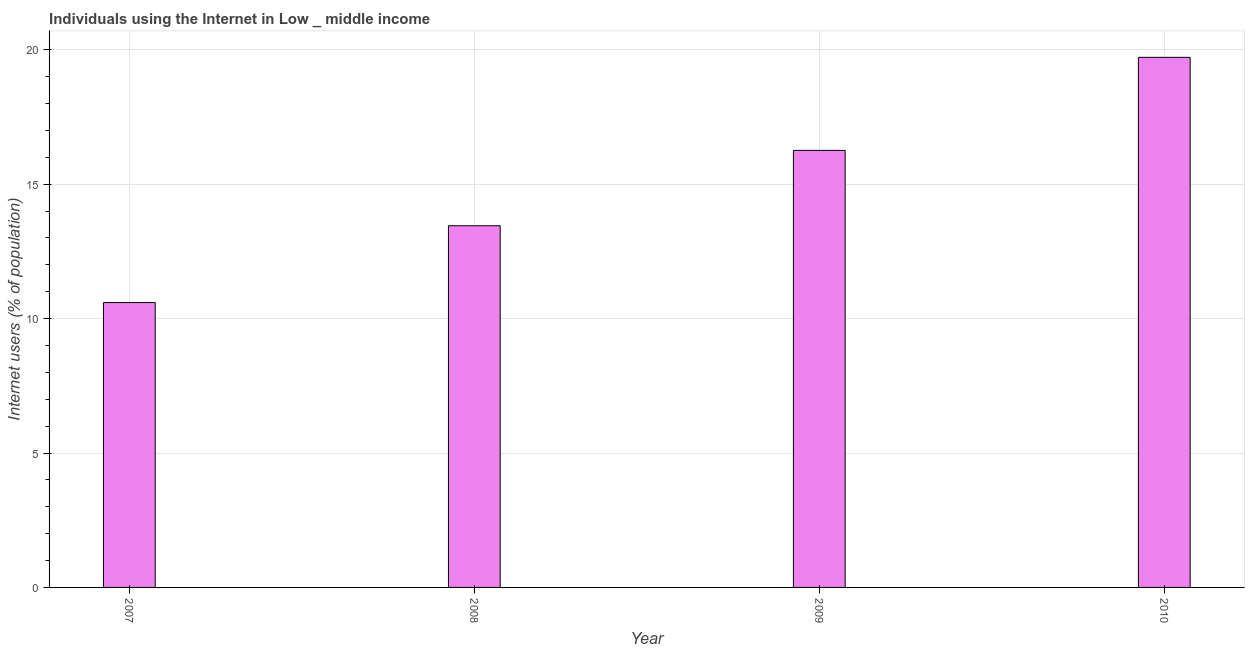Does the graph contain any zero values?
Give a very brief answer. No. What is the title of the graph?
Give a very brief answer. Individuals using the Internet in Low _ middle income. What is the label or title of the Y-axis?
Give a very brief answer. Internet users (% of population). What is the number of internet users in 2008?
Offer a very short reply. 13.46. Across all years, what is the maximum number of internet users?
Offer a very short reply. 19.72. Across all years, what is the minimum number of internet users?
Your response must be concise. 10.6. What is the sum of the number of internet users?
Offer a terse response. 60.03. What is the difference between the number of internet users in 2008 and 2010?
Provide a succinct answer. -6.27. What is the average number of internet users per year?
Give a very brief answer. 15.01. What is the median number of internet users?
Your answer should be compact. 14.86. What is the ratio of the number of internet users in 2008 to that in 2009?
Keep it short and to the point. 0.83. Is the number of internet users in 2007 less than that in 2009?
Your response must be concise. Yes. What is the difference between the highest and the second highest number of internet users?
Make the answer very short. 3.46. Is the sum of the number of internet users in 2008 and 2010 greater than the maximum number of internet users across all years?
Offer a terse response. Yes. What is the difference between the highest and the lowest number of internet users?
Ensure brevity in your answer.  9.12. In how many years, is the number of internet users greater than the average number of internet users taken over all years?
Make the answer very short. 2. How many bars are there?
Provide a short and direct response. 4. How many years are there in the graph?
Offer a terse response. 4. What is the difference between two consecutive major ticks on the Y-axis?
Ensure brevity in your answer.  5. What is the Internet users (% of population) of 2007?
Your answer should be compact. 10.6. What is the Internet users (% of population) of 2008?
Your answer should be compact. 13.46. What is the Internet users (% of population) of 2009?
Keep it short and to the point. 16.26. What is the Internet users (% of population) in 2010?
Keep it short and to the point. 19.72. What is the difference between the Internet users (% of population) in 2007 and 2008?
Provide a succinct answer. -2.86. What is the difference between the Internet users (% of population) in 2007 and 2009?
Offer a very short reply. -5.66. What is the difference between the Internet users (% of population) in 2007 and 2010?
Make the answer very short. -9.12. What is the difference between the Internet users (% of population) in 2008 and 2009?
Provide a short and direct response. -2.8. What is the difference between the Internet users (% of population) in 2008 and 2010?
Keep it short and to the point. -6.27. What is the difference between the Internet users (% of population) in 2009 and 2010?
Offer a very short reply. -3.46. What is the ratio of the Internet users (% of population) in 2007 to that in 2008?
Offer a terse response. 0.79. What is the ratio of the Internet users (% of population) in 2007 to that in 2009?
Keep it short and to the point. 0.65. What is the ratio of the Internet users (% of population) in 2007 to that in 2010?
Make the answer very short. 0.54. What is the ratio of the Internet users (% of population) in 2008 to that in 2009?
Make the answer very short. 0.83. What is the ratio of the Internet users (% of population) in 2008 to that in 2010?
Your response must be concise. 0.68. What is the ratio of the Internet users (% of population) in 2009 to that in 2010?
Provide a short and direct response. 0.82. 